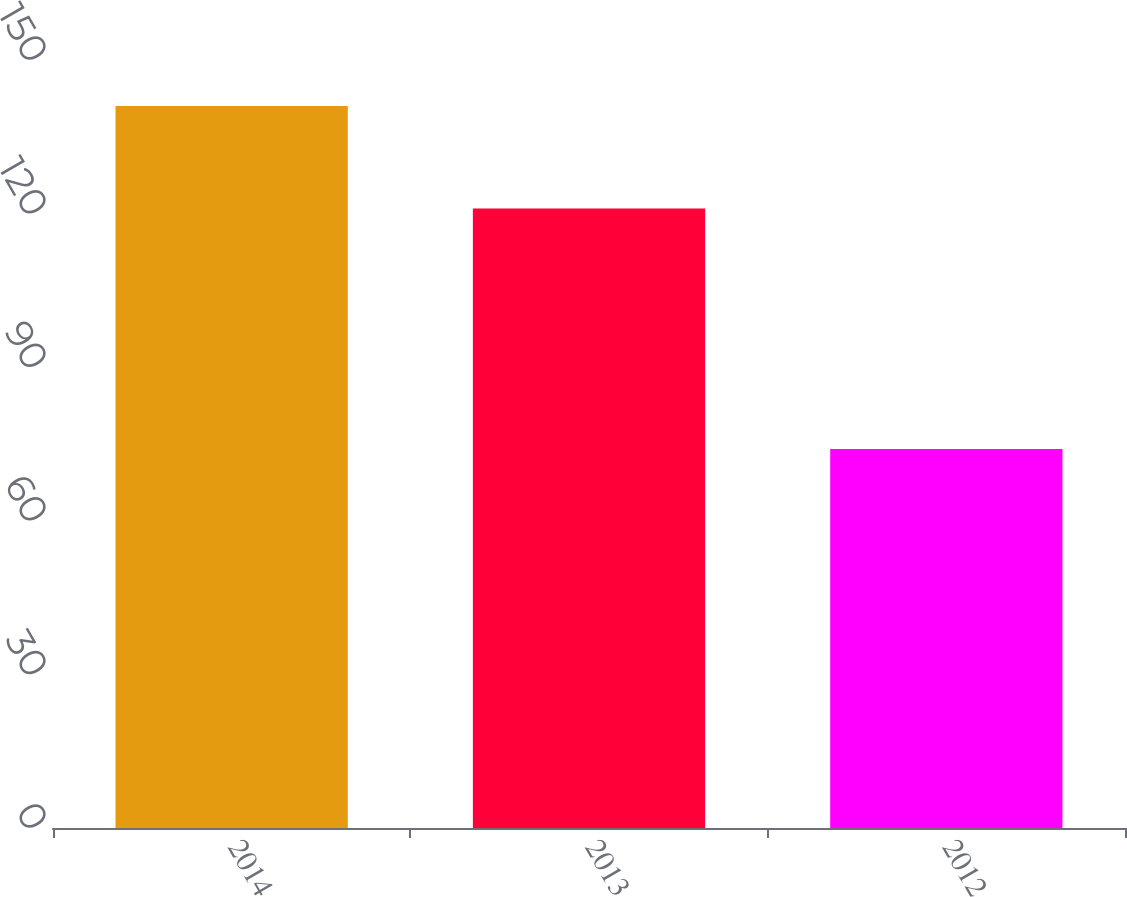<chart> <loc_0><loc_0><loc_500><loc_500><bar_chart><fcel>2014<fcel>2013<fcel>2012<nl><fcel>141<fcel>121<fcel>74<nl></chart> 